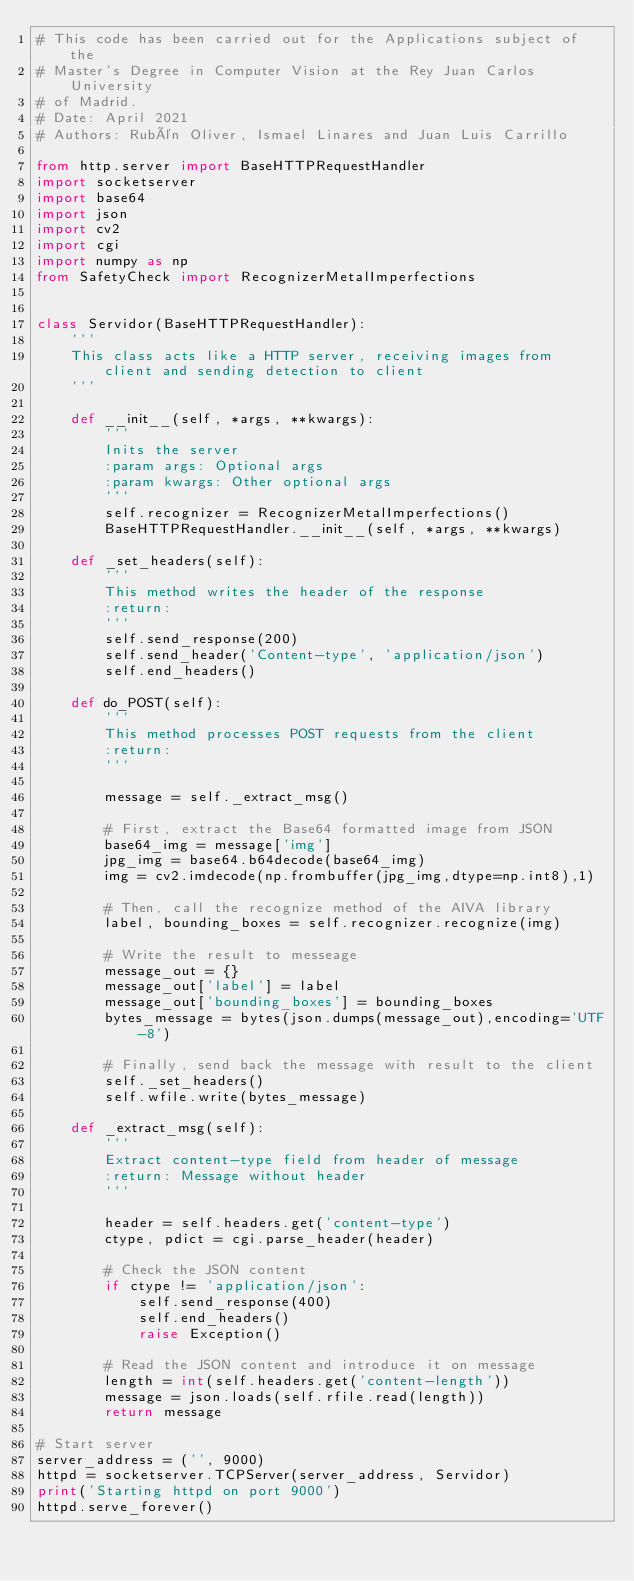Convert code to text. <code><loc_0><loc_0><loc_500><loc_500><_Python_># This code has been carried out for the Applications subject of the
# Master's Degree in Computer Vision at the Rey Juan Carlos University
# of Madrid.
# Date: April 2021
# Authors: Rubén Oliver, Ismael Linares and Juan Luis Carrillo

from http.server import BaseHTTPRequestHandler
import socketserver
import base64
import json
import cv2
import cgi
import numpy as np
from SafetyCheck import RecognizerMetalImperfections


class Servidor(BaseHTTPRequestHandler):
    '''
    This class acts like a HTTP server, receiving images from client and sending detection to client
    '''

    def __init__(self, *args, **kwargs):
        '''
        Inits the server
        :param args: Optional args
        :param kwargs: Other optional args
        '''
        self.recognizer = RecognizerMetalImperfections()
        BaseHTTPRequestHandler.__init__(self, *args, **kwargs)

    def _set_headers(self):
        '''
        This method writes the header of the response
        :return:
        '''
        self.send_response(200)
        self.send_header('Content-type', 'application/json')
        self.end_headers()

    def do_POST(self):
        '''
        This method processes POST requests from the client
        :return:
        '''

        message = self._extract_msg()

        # First, extract the Base64 formatted image from JSON
        base64_img = message['img']
        jpg_img = base64.b64decode(base64_img)
        img = cv2.imdecode(np.frombuffer(jpg_img,dtype=np.int8),1)

        # Then, call the recognize method of the AIVA library
        label, bounding_boxes = self.recognizer.recognize(img)

        # Write the result to messeage
        message_out = {}
        message_out['label'] = label
        message_out['bounding_boxes'] = bounding_boxes
        bytes_message = bytes(json.dumps(message_out),encoding='UTF-8')

        # Finally, send back the message with result to the client
        self._set_headers()
        self.wfile.write(bytes_message)

    def _extract_msg(self):
        '''
        Extract content-type field from header of message
        :return: Message without header
        '''

        header = self.headers.get('content-type')
        ctype, pdict = cgi.parse_header(header)

        # Check the JSON content
        if ctype != 'application/json':
            self.send_response(400)
            self.end_headers()
            raise Exception()

        # Read the JSON content and introduce it on message
        length = int(self.headers.get('content-length'))
        message = json.loads(self.rfile.read(length))
        return message

# Start server
server_address = ('', 9000)
httpd = socketserver.TCPServer(server_address, Servidor)
print('Starting httpd on port 9000')
httpd.serve_forever()
</code> 